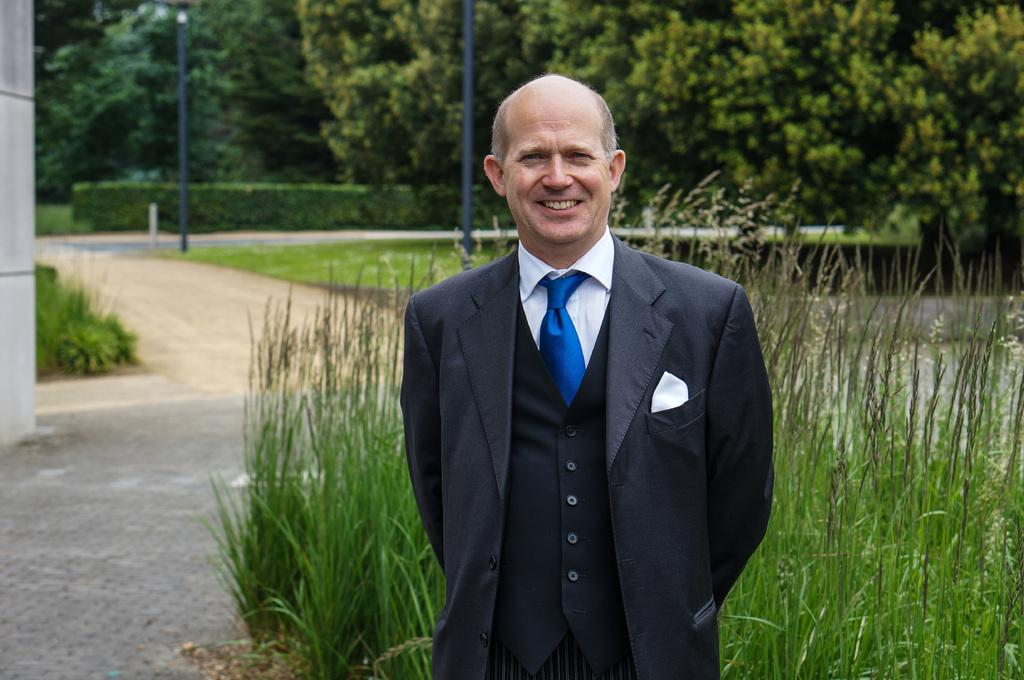What is the main subject of the image? There is a man in the image. What is the man doing in the image? The man is standing in the image. What is the man's facial expression in the image? The man is smiling in the image. What can be seen in the background of the image? There are trees, bushes, poles, roads, and grass in the background of the image. What type of school can be seen in the image? There is no school present in the image. How many arms does the man have in the image? The man has two arms in the image, but this question is irrelevant as the number of arms is not a relevant detail in the image. 